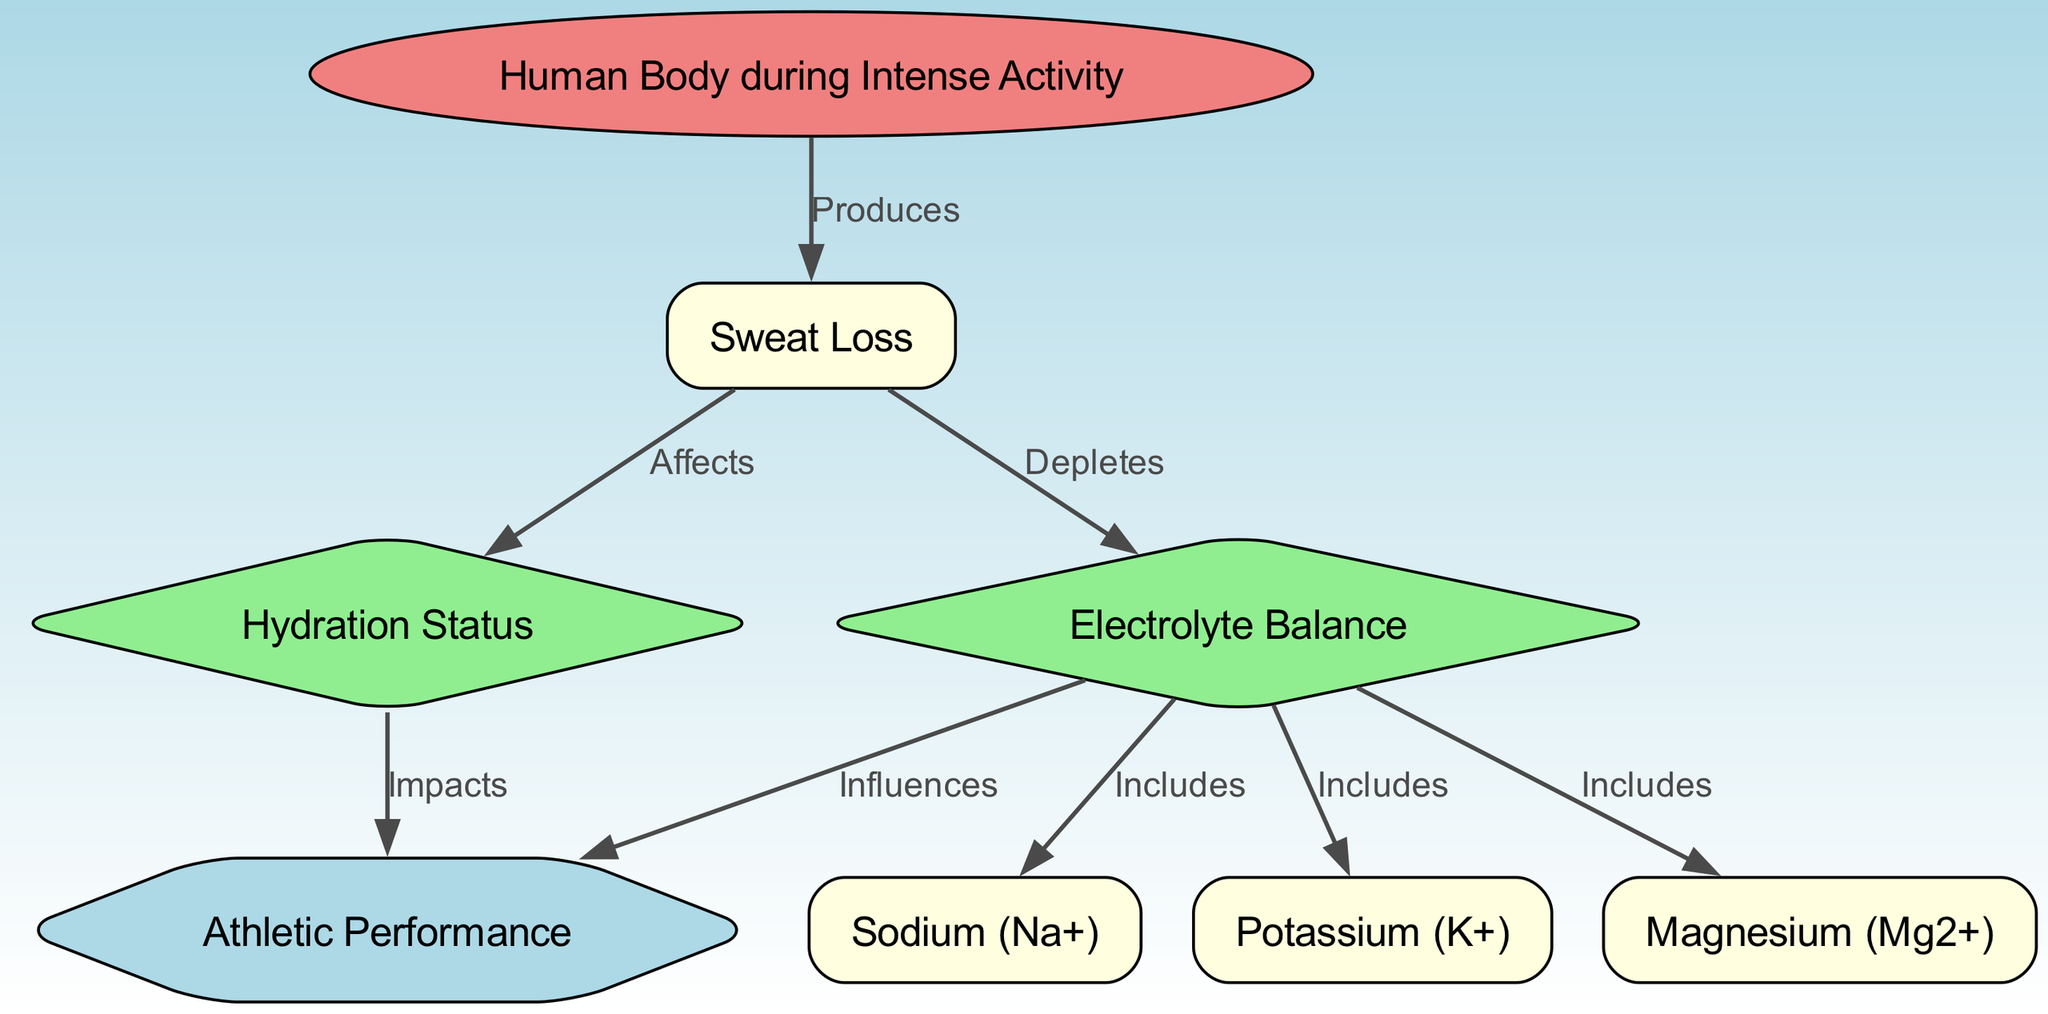What is affected by sweat loss? The diagram directly links sweat loss to hydration status, highlighting that sweat loss affects how hydrated the body is during intense activity.
Answer: Hydration Status How many electrolytes are included in the diagram? The diagram lists three specific electrolytes: Sodium, Potassium, and Magnesium, which are all included under the electrolyte balance relationship.
Answer: Three What body part produces sweat? The diagram connects the human body to sweat production, indicating that the body's response during intense activity results in sweat loss.
Answer: Human Body What influences athletic performance according to the diagram? The diagram shows that both hydration status and electrolyte balance have direct influences on athletic performance during intense physical activity.
Answer: Hydration Status and Electrolyte Balance How does sweat loss affect electrolyte balance? The diagram indicates that sweat loss depletes electrolyte levels in the body, directly linking these two elements together in the context of intense physical activity.
Answer: Depletes What type of diagram is this? The structure and content of the diagram clearly categorize it as a biomedical diagram, as it visually represents physiological concepts related specifically to human bodily functions.
Answer: Biomedical Diagram Which electrolyte is represented as Na+? Among the electrolytes listed in the diagram, Sodium is denoted with the chemical symbol Na+, confirming it as the specific electrolyte represented.
Answer: Sodium What does hydration status impact? According to the diagram, hydration status impacts athletic performance, indicating a direct relationship between how well-hydrated an athlete is and their performance level.
Answer: Athletic Performance 